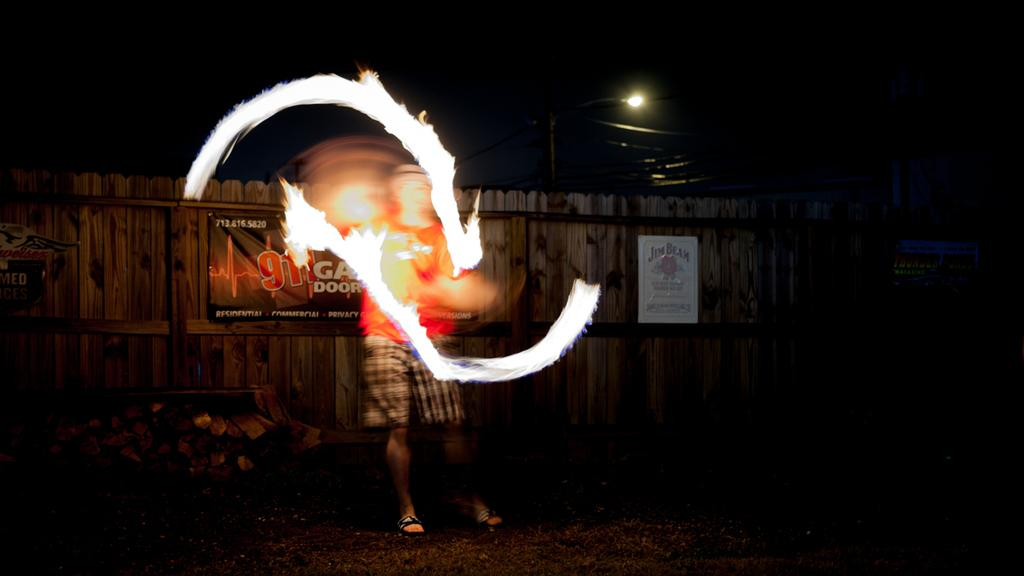What is the main subject in the image? There is a person in the image. What else can be seen in the image besides the person? There are posters and a lamp visible in the image. What type of lunch is the person eating in the image? There is no indication in the image that the person is eating lunch, so it cannot be determined from the picture. 